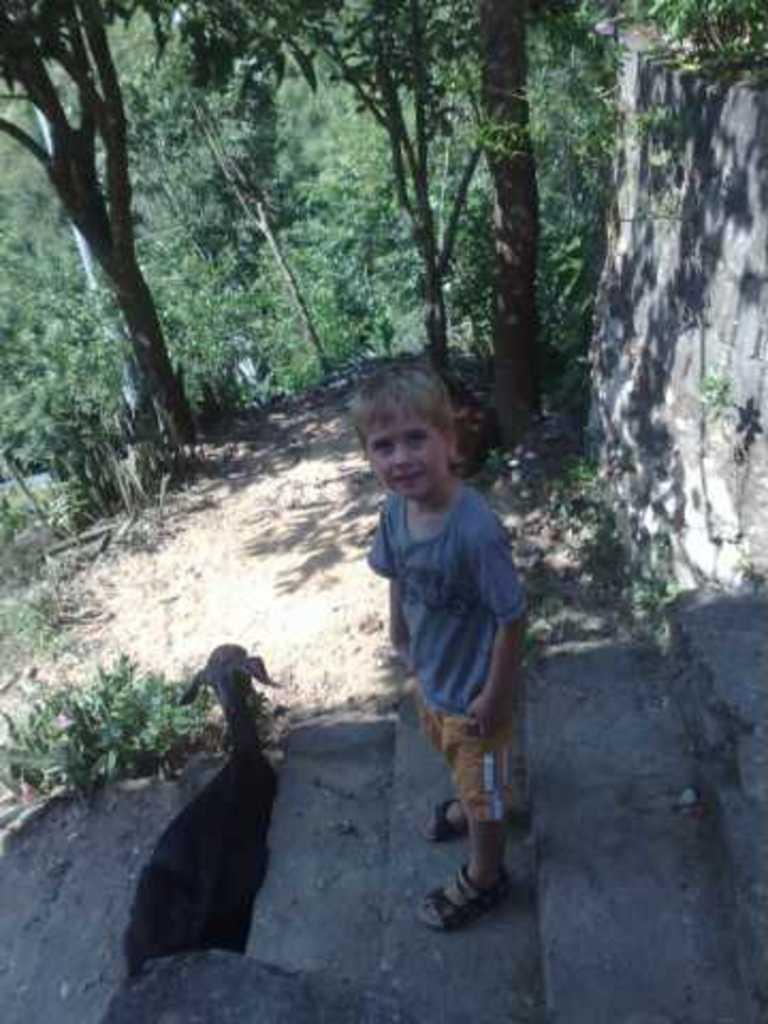What is the boy doing in the image? The boy is standing on the stair in the image. What animal is present in the image? There is a sheep in the image. What can be seen in the background of the image? The ground, plants, trees, and a wall are visible in the background of the image. What songs is the sheep singing in the image? Sheep do not sing songs, and there is no indication of any songs being sung in the image. 